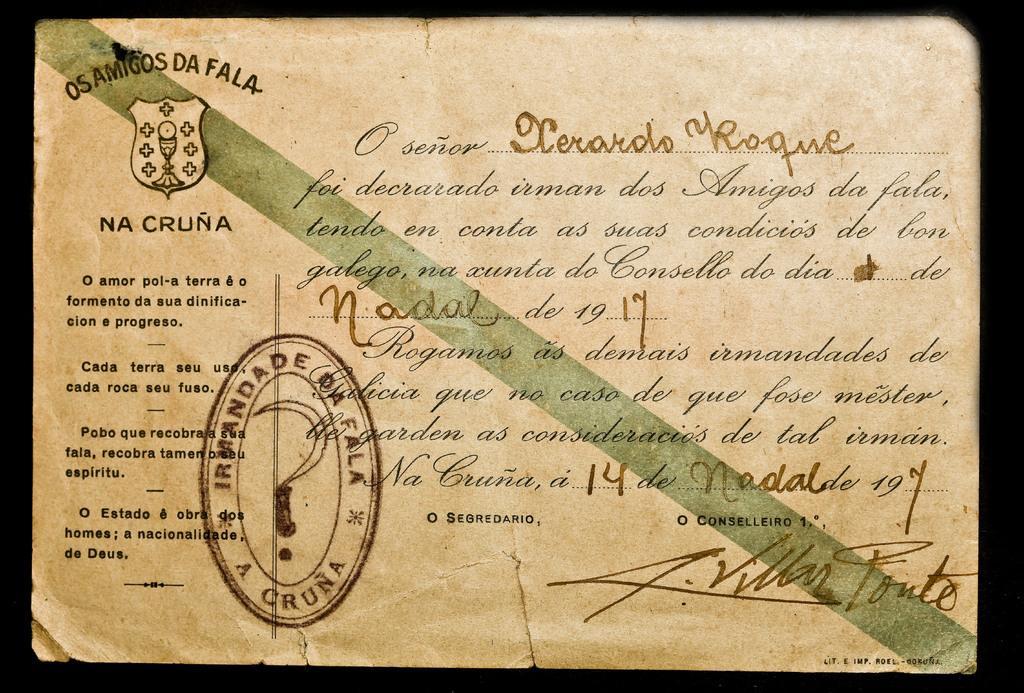In one or two sentences, can you explain what this image depicts? This is the certificate with some text, logo and stamp. 